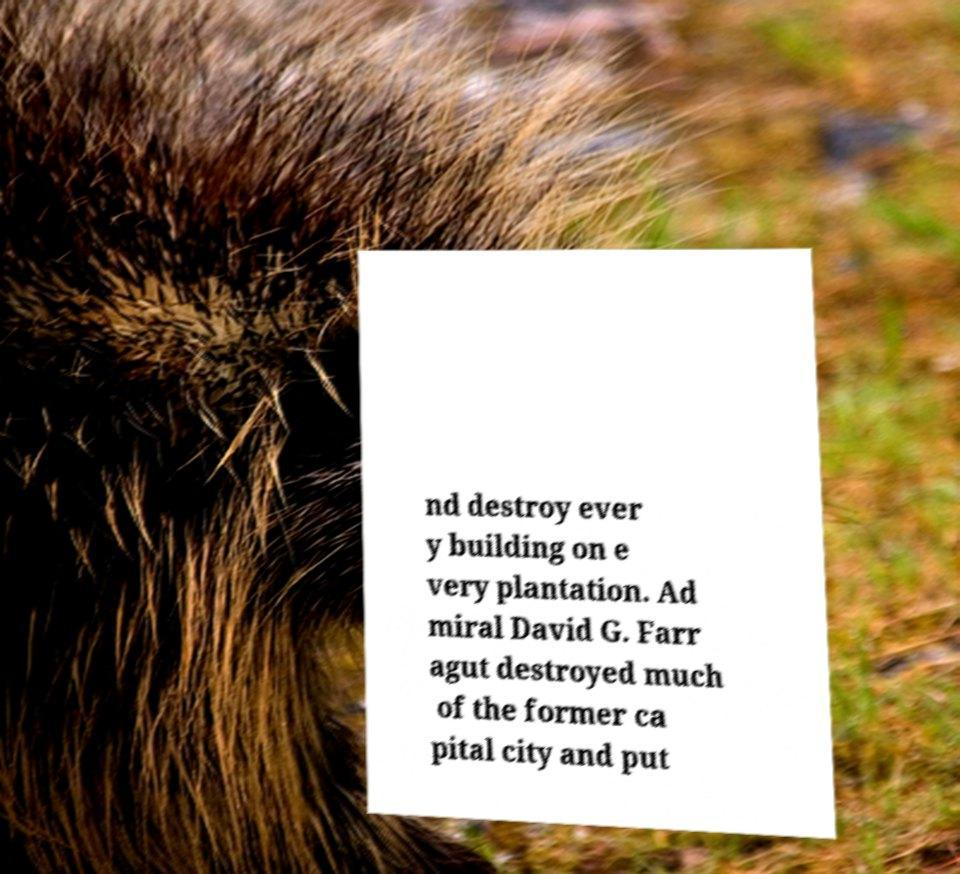Please identify and transcribe the text found in this image. nd destroy ever y building on e very plantation. Ad miral David G. Farr agut destroyed much of the former ca pital city and put 